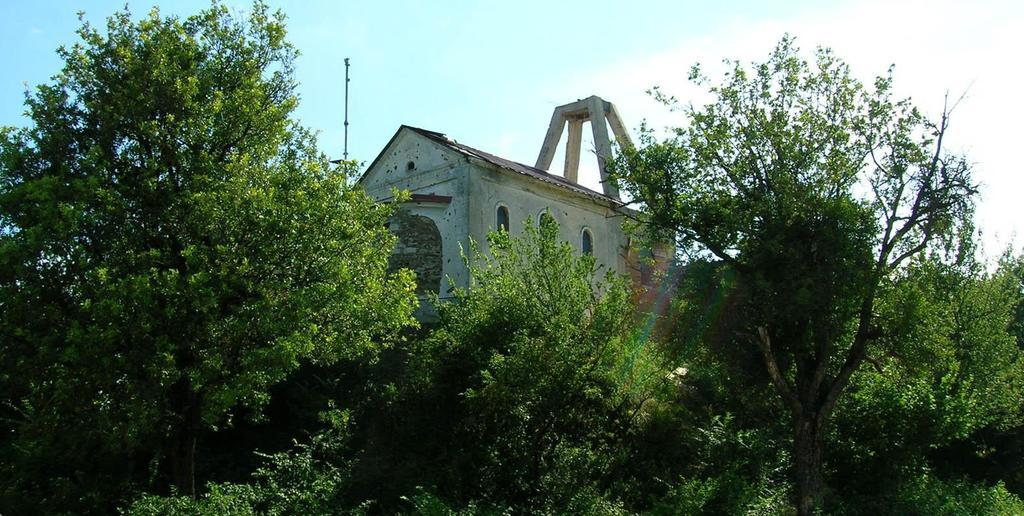What type of vegetation is present in the image? There are green color trees in the image. What structure can be seen in the image? There is a house in the image. What color is the sky in the image? The sky is blue in color. What type of drawer is visible in the image? There is no drawer present in the image. Who needs to approve the house in the image? The image does not show any approval process, and there is no indication of who might need to approve the house. 